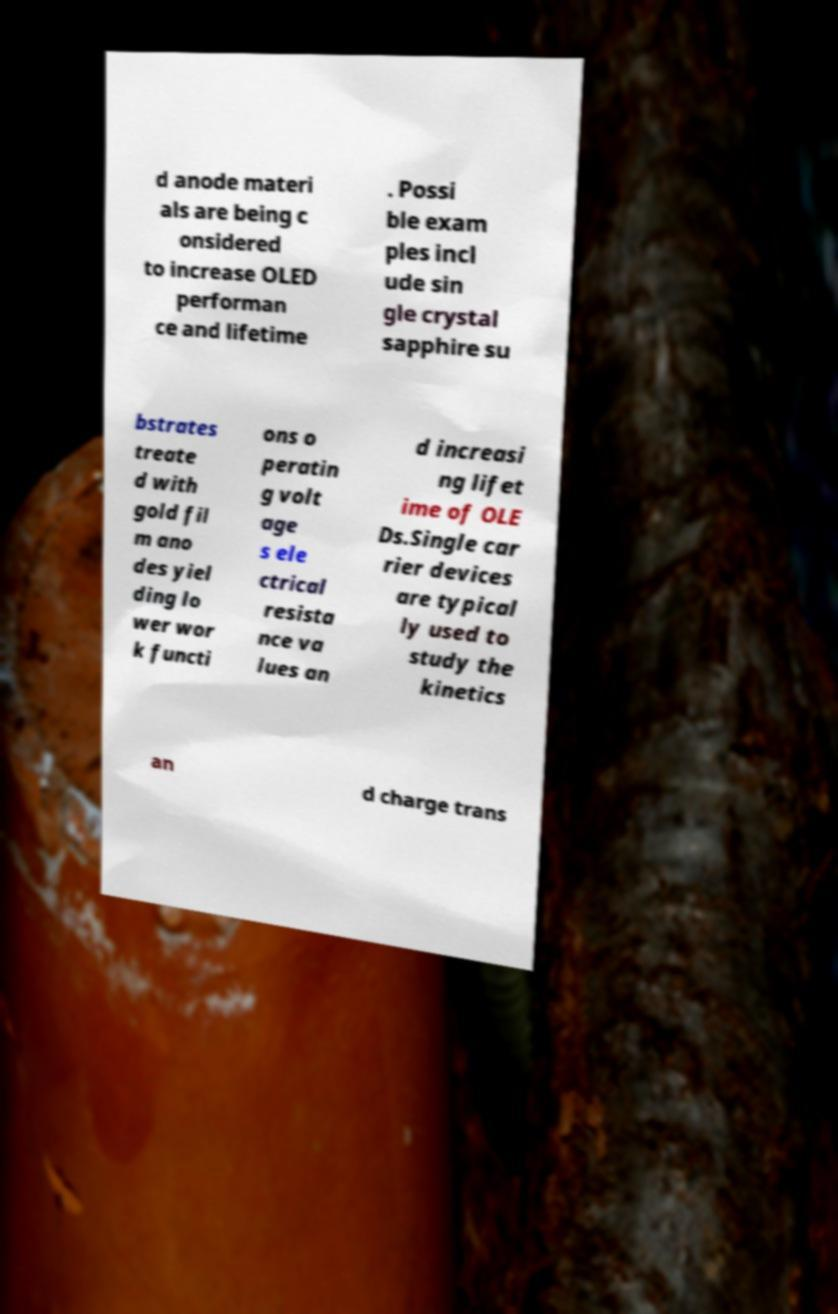There's text embedded in this image that I need extracted. Can you transcribe it verbatim? d anode materi als are being c onsidered to increase OLED performan ce and lifetime . Possi ble exam ples incl ude sin gle crystal sapphire su bstrates treate d with gold fil m ano des yiel ding lo wer wor k functi ons o peratin g volt age s ele ctrical resista nce va lues an d increasi ng lifet ime of OLE Ds.Single car rier devices are typical ly used to study the kinetics an d charge trans 